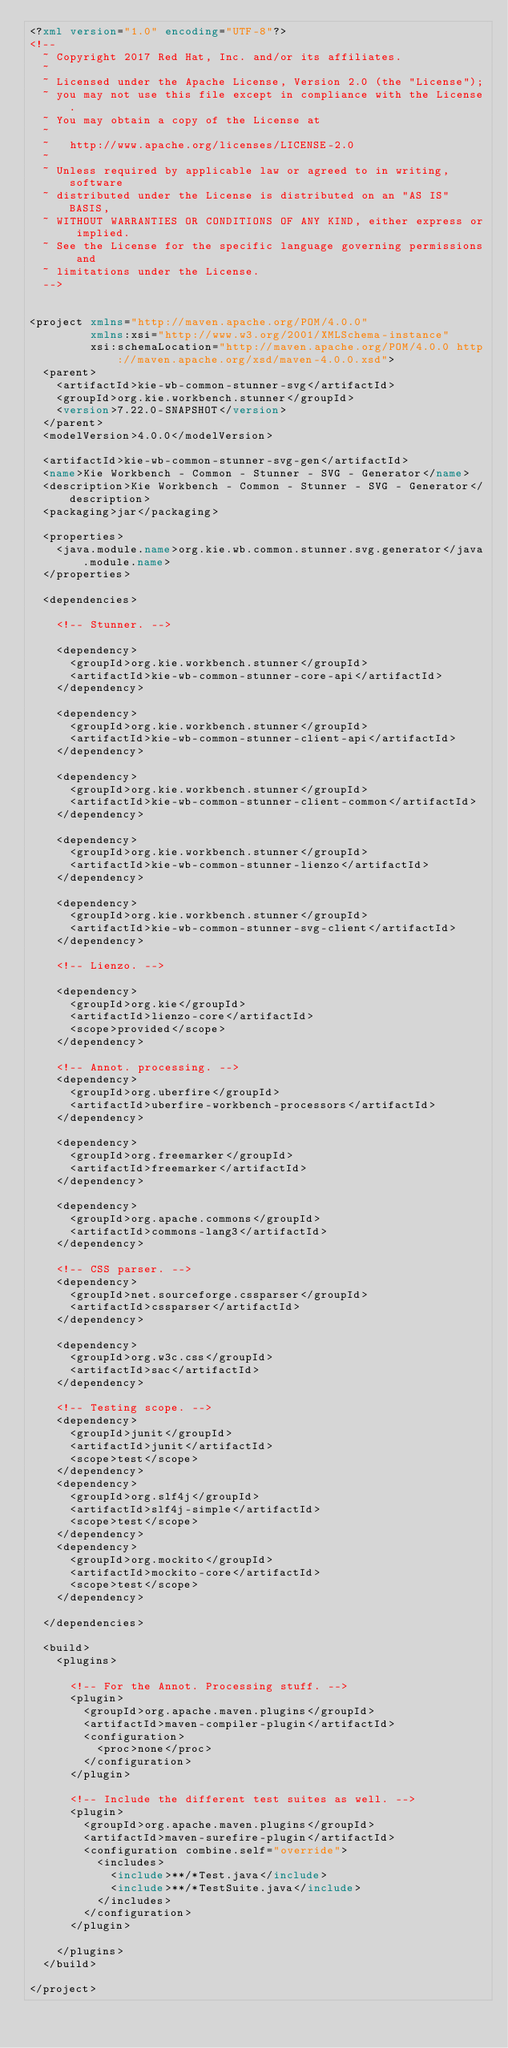Convert code to text. <code><loc_0><loc_0><loc_500><loc_500><_XML_><?xml version="1.0" encoding="UTF-8"?>
<!--
  ~ Copyright 2017 Red Hat, Inc. and/or its affiliates.
  ~
  ~ Licensed under the Apache License, Version 2.0 (the "License");
  ~ you may not use this file except in compliance with the License.
  ~ You may obtain a copy of the License at
  ~
  ~   http://www.apache.org/licenses/LICENSE-2.0
  ~
  ~ Unless required by applicable law or agreed to in writing, software
  ~ distributed under the License is distributed on an "AS IS" BASIS,
  ~ WITHOUT WARRANTIES OR CONDITIONS OF ANY KIND, either express or implied.
  ~ See the License for the specific language governing permissions and
  ~ limitations under the License.
  -->


<project xmlns="http://maven.apache.org/POM/4.0.0"
         xmlns:xsi="http://www.w3.org/2001/XMLSchema-instance"
         xsi:schemaLocation="http://maven.apache.org/POM/4.0.0 http://maven.apache.org/xsd/maven-4.0.0.xsd">
  <parent>
    <artifactId>kie-wb-common-stunner-svg</artifactId>
    <groupId>org.kie.workbench.stunner</groupId>
    <version>7.22.0-SNAPSHOT</version>
  </parent>
  <modelVersion>4.0.0</modelVersion>

  <artifactId>kie-wb-common-stunner-svg-gen</artifactId>
  <name>Kie Workbench - Common - Stunner - SVG - Generator</name>
  <description>Kie Workbench - Common - Stunner - SVG - Generator</description>
  <packaging>jar</packaging>

  <properties>
    <java.module.name>org.kie.wb.common.stunner.svg.generator</java.module.name>
  </properties>

  <dependencies>

    <!-- Stunner. -->

    <dependency>
      <groupId>org.kie.workbench.stunner</groupId>
      <artifactId>kie-wb-common-stunner-core-api</artifactId>
    </dependency>

    <dependency>
      <groupId>org.kie.workbench.stunner</groupId>
      <artifactId>kie-wb-common-stunner-client-api</artifactId>
    </dependency>

    <dependency>
      <groupId>org.kie.workbench.stunner</groupId>
      <artifactId>kie-wb-common-stunner-client-common</artifactId>
    </dependency>

    <dependency>
      <groupId>org.kie.workbench.stunner</groupId>
      <artifactId>kie-wb-common-stunner-lienzo</artifactId>
    </dependency>

    <dependency>
      <groupId>org.kie.workbench.stunner</groupId>
      <artifactId>kie-wb-common-stunner-svg-client</artifactId>
    </dependency>

    <!-- Lienzo. -->

    <dependency>
      <groupId>org.kie</groupId>
      <artifactId>lienzo-core</artifactId>
      <scope>provided</scope>
    </dependency>

    <!-- Annot. processing. -->
    <dependency>
      <groupId>org.uberfire</groupId>
      <artifactId>uberfire-workbench-processors</artifactId>
    </dependency>

    <dependency>
      <groupId>org.freemarker</groupId>
      <artifactId>freemarker</artifactId>
    </dependency>

    <dependency>
      <groupId>org.apache.commons</groupId>
      <artifactId>commons-lang3</artifactId>
    </dependency>

    <!-- CSS parser. -->
    <dependency>
      <groupId>net.sourceforge.cssparser</groupId>
      <artifactId>cssparser</artifactId>
    </dependency>

    <dependency>
      <groupId>org.w3c.css</groupId>
      <artifactId>sac</artifactId>
    </dependency>

    <!-- Testing scope. -->
    <dependency>
      <groupId>junit</groupId>
      <artifactId>junit</artifactId>
      <scope>test</scope>
    </dependency>
    <dependency>
      <groupId>org.slf4j</groupId>
      <artifactId>slf4j-simple</artifactId>
      <scope>test</scope>
    </dependency>
    <dependency>
      <groupId>org.mockito</groupId>
      <artifactId>mockito-core</artifactId>
      <scope>test</scope>
    </dependency>

  </dependencies>

  <build>
    <plugins>

      <!-- For the Annot. Processing stuff. -->
      <plugin>
        <groupId>org.apache.maven.plugins</groupId>
        <artifactId>maven-compiler-plugin</artifactId>
        <configuration>
          <proc>none</proc>
        </configuration>
      </plugin>

      <!-- Include the different test suites as well. -->
      <plugin>
        <groupId>org.apache.maven.plugins</groupId>
        <artifactId>maven-surefire-plugin</artifactId>
        <configuration combine.self="override">
          <includes>
            <include>**/*Test.java</include>
            <include>**/*TestSuite.java</include>
          </includes>
        </configuration>
      </plugin>

    </plugins>
  </build>

</project>
</code> 